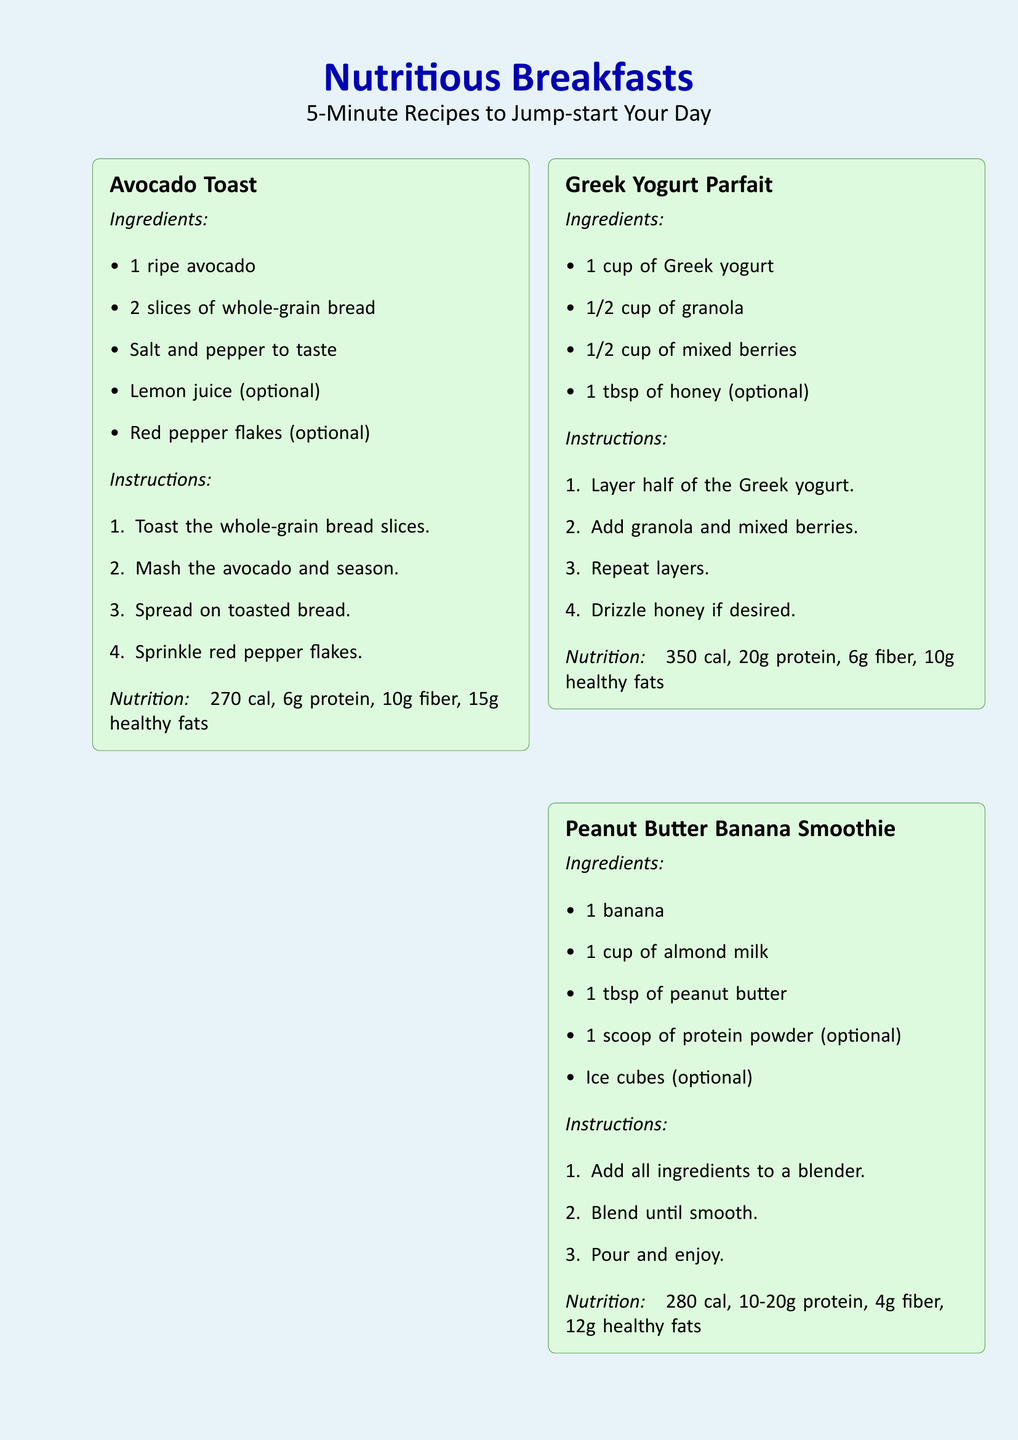What are the ingredients for Avocado Toast? The ingredients list for Avocado Toast includes 1 ripe avocado, 2 slices of whole-grain bread, salt and pepper to taste, lemon juice (optional), and red pepper flakes (optional).
Answer: 1 ripe avocado, 2 slices of whole-grain bread, salt and pepper, lemon juice, red pepper flakes How many calories are in the Greek Yogurt Parfait? The nutrition information for the Greek Yogurt Parfait states it contains 350 calories.
Answer: 350 cal What is the main ingredient in the Peanut Butter Banana Smoothie? The Peanut Butter Banana Smoothie primarily contains 1 banana as its main ingredient.
Answer: 1 banana What is the total fiber content in Overnight Chia Pudding? The nutrition details for Overnight Chia Pudding indicate it has 10 grams of fiber.
Answer: 10g fiber How long should the Overnight Chia Pudding be refrigerated? The instructions specify to refrigerate the Overnight Chia Pudding overnight, which implies at least several hours.
Answer: Overnight Which recipe contains eggs? The recipe for Quick Egg & Veggie Scramble includes eggs as a primary ingredient.
Answer: Quick Egg & Veggie Scramble What optional ingredient can be added to the Greek Yogurt Parfait for sweetness? Honey can be added as an optional sweetener to the Greek Yogurt Parfait.
Answer: Honey How quickly can these recipes be prepared? The document notes that these recipes can be prepared in just 5 minutes.
Answer: 5 minutes 